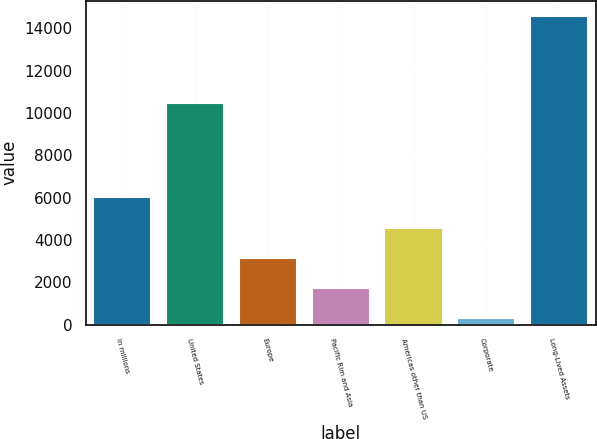Convert chart. <chart><loc_0><loc_0><loc_500><loc_500><bar_chart><fcel>In millions<fcel>United States<fcel>Europe<fcel>Pacific Rim and Asia<fcel>Americas other than US<fcel>Corporate<fcel>Long-Lived Assets<nl><fcel>6014.4<fcel>10484<fcel>3162.2<fcel>1736.1<fcel>4588.3<fcel>310<fcel>14571<nl></chart> 